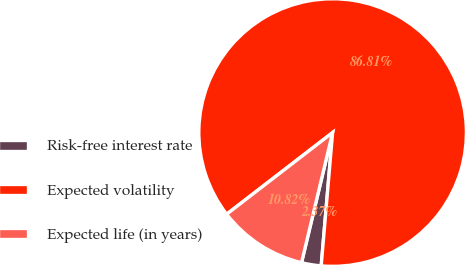Convert chart. <chart><loc_0><loc_0><loc_500><loc_500><pie_chart><fcel>Risk-free interest rate<fcel>Expected volatility<fcel>Expected life (in years)<nl><fcel>2.37%<fcel>86.82%<fcel>10.82%<nl></chart> 